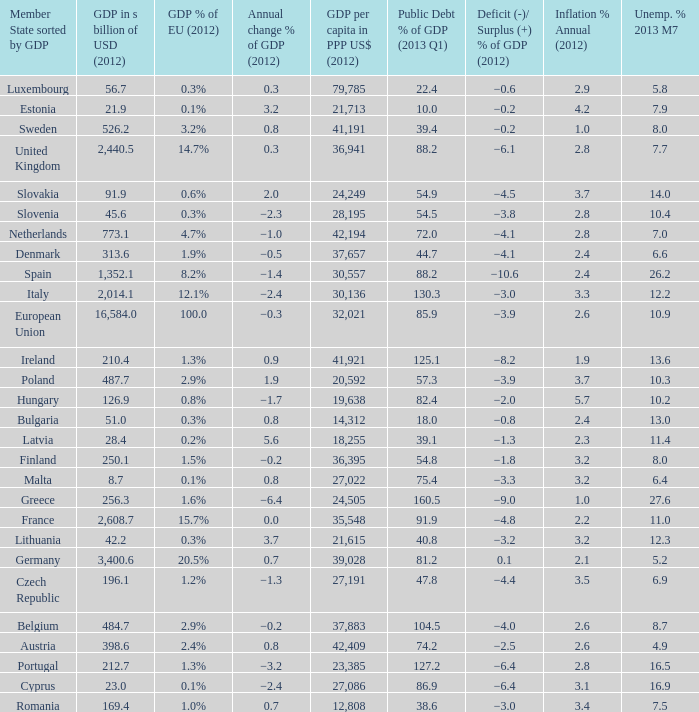What is the GDP % of EU in 2012 of the country with a GDP in billions of USD in 2012 of 256.3? 1.6%. 